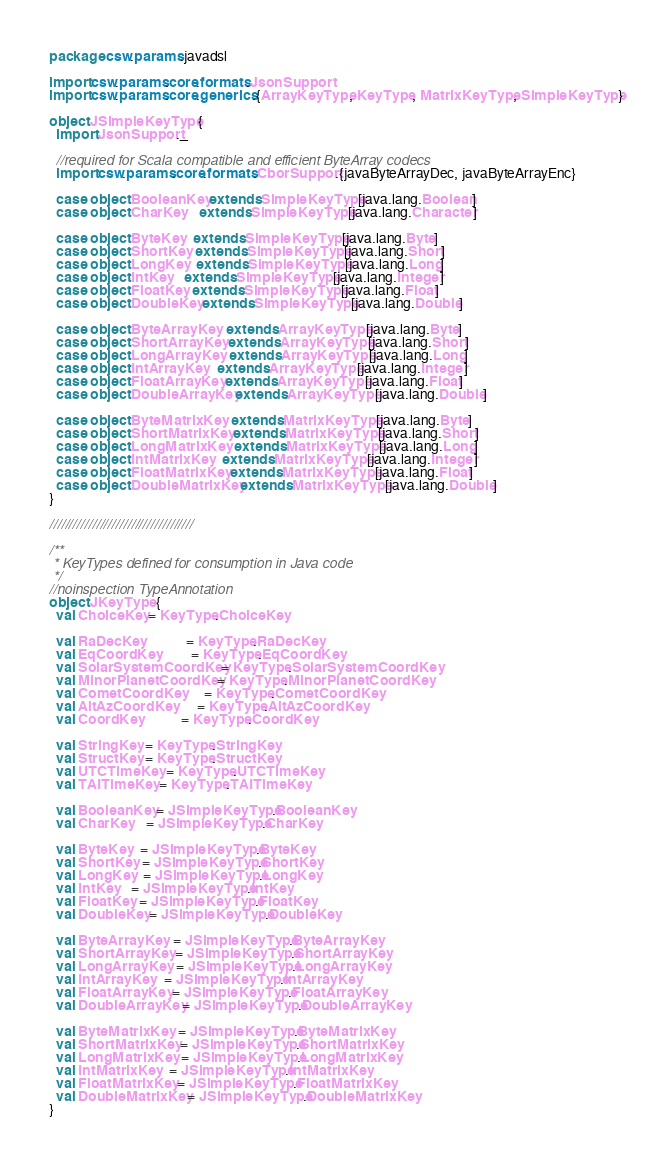<code> <loc_0><loc_0><loc_500><loc_500><_Scala_>package csw.params.javadsl

import csw.params.core.formats.JsonSupport
import csw.params.core.generics.{ArrayKeyType, KeyType, MatrixKeyType, SimpleKeyType}

object JSimpleKeyType {
  import JsonSupport._

  //required for Scala compatible and efficient ByteArray codecs
  import csw.params.core.formats.CborSupport.{javaByteArrayDec, javaByteArrayEnc}

  case object BooleanKey extends SimpleKeyType[java.lang.Boolean]
  case object CharKey    extends SimpleKeyType[java.lang.Character]

  case object ByteKey   extends SimpleKeyType[java.lang.Byte]
  case object ShortKey  extends SimpleKeyType[java.lang.Short]
  case object LongKey   extends SimpleKeyType[java.lang.Long]
  case object IntKey    extends SimpleKeyType[java.lang.Integer]
  case object FloatKey  extends SimpleKeyType[java.lang.Float]
  case object DoubleKey extends SimpleKeyType[java.lang.Double]

  case object ByteArrayKey   extends ArrayKeyType[java.lang.Byte]
  case object ShortArrayKey  extends ArrayKeyType[java.lang.Short]
  case object LongArrayKey   extends ArrayKeyType[java.lang.Long]
  case object IntArrayKey    extends ArrayKeyType[java.lang.Integer]
  case object FloatArrayKey  extends ArrayKeyType[java.lang.Float]
  case object DoubleArrayKey extends ArrayKeyType[java.lang.Double]

  case object ByteMatrixKey   extends MatrixKeyType[java.lang.Byte]
  case object ShortMatrixKey  extends MatrixKeyType[java.lang.Short]
  case object LongMatrixKey   extends MatrixKeyType[java.lang.Long]
  case object IntMatrixKey    extends MatrixKeyType[java.lang.Integer]
  case object FloatMatrixKey  extends MatrixKeyType[java.lang.Float]
  case object DoubleMatrixKey extends MatrixKeyType[java.lang.Double]
}

/////////////////////////////////////

/**
 * KeyTypes defined for consumption in Java code
 */
//noinspection TypeAnnotation
object JKeyType {
  val ChoiceKey = KeyType.ChoiceKey

  val RaDecKey            = KeyType.RaDecKey
  val EqCoordKey          = KeyType.EqCoordKey
  val SolarSystemCoordKey = KeyType.SolarSystemCoordKey
  val MinorPlanetCoordKey = KeyType.MinorPlanetCoordKey
  val CometCoordKey       = KeyType.CometCoordKey
  val AltAzCoordKey       = KeyType.AltAzCoordKey
  val CoordKey            = KeyType.CoordKey

  val StringKey  = KeyType.StringKey
  val StructKey  = KeyType.StructKey
  val UTCTimeKey = KeyType.UTCTimeKey
  val TAITimeKey = KeyType.TAITimeKey

  val BooleanKey = JSimpleKeyType.BooleanKey
  val CharKey    = JSimpleKeyType.CharKey

  val ByteKey   = JSimpleKeyType.ByteKey
  val ShortKey  = JSimpleKeyType.ShortKey
  val LongKey   = JSimpleKeyType.LongKey
  val IntKey    = JSimpleKeyType.IntKey
  val FloatKey  = JSimpleKeyType.FloatKey
  val DoubleKey = JSimpleKeyType.DoubleKey

  val ByteArrayKey   = JSimpleKeyType.ByteArrayKey
  val ShortArrayKey  = JSimpleKeyType.ShortArrayKey
  val LongArrayKey   = JSimpleKeyType.LongArrayKey
  val IntArrayKey    = JSimpleKeyType.IntArrayKey
  val FloatArrayKey  = JSimpleKeyType.FloatArrayKey
  val DoubleArrayKey = JSimpleKeyType.DoubleArrayKey

  val ByteMatrixKey   = JSimpleKeyType.ByteMatrixKey
  val ShortMatrixKey  = JSimpleKeyType.ShortMatrixKey
  val LongMatrixKey   = JSimpleKeyType.LongMatrixKey
  val IntMatrixKey    = JSimpleKeyType.IntMatrixKey
  val FloatMatrixKey  = JSimpleKeyType.FloatMatrixKey
  val DoubleMatrixKey = JSimpleKeyType.DoubleMatrixKey
}
</code> 